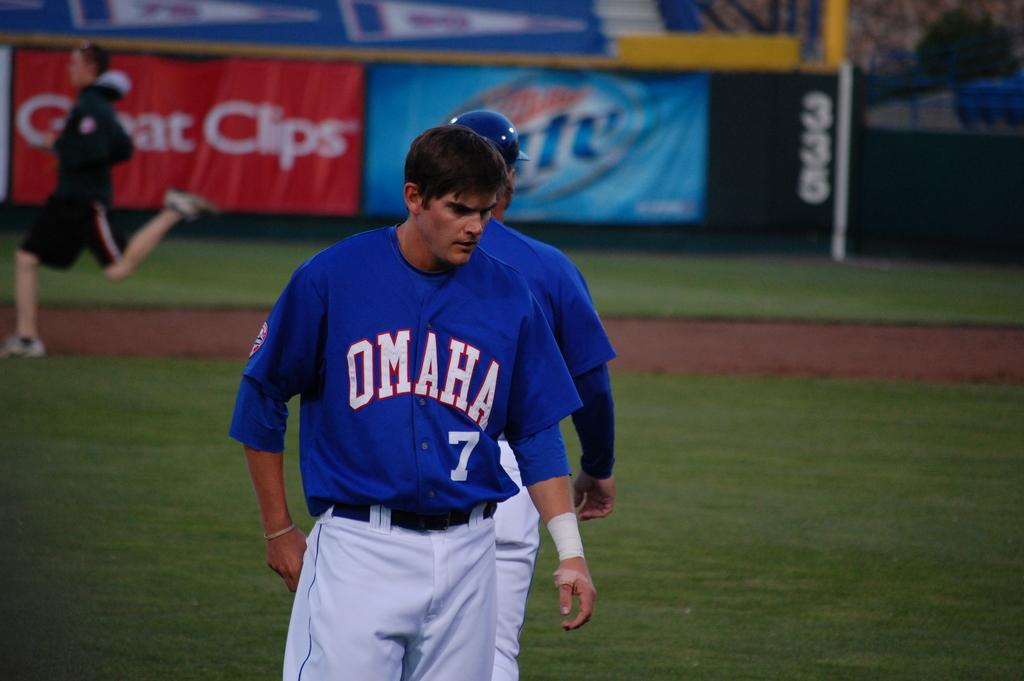Provide a one-sentence caption for the provided image. a baseball player with omaha jersey number 7. 